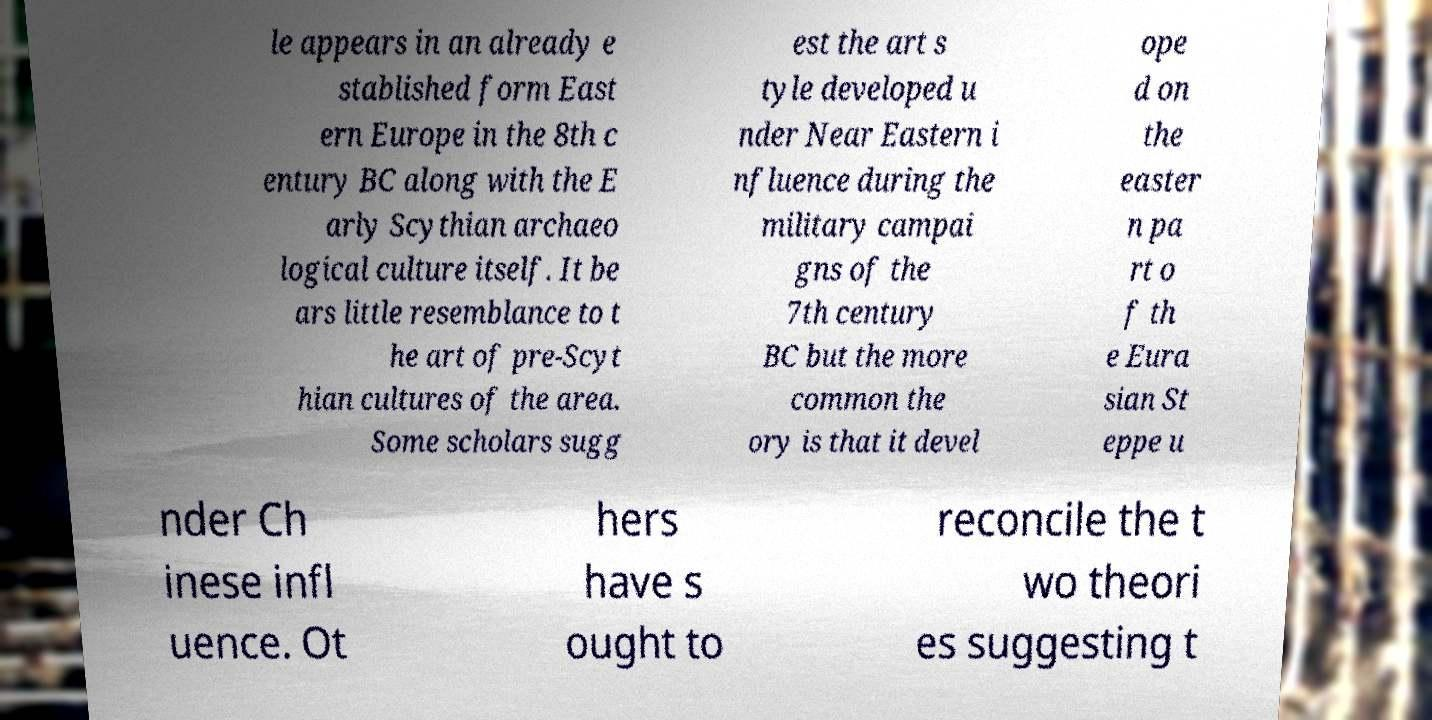Could you extract and type out the text from this image? le appears in an already e stablished form East ern Europe in the 8th c entury BC along with the E arly Scythian archaeo logical culture itself. It be ars little resemblance to t he art of pre-Scyt hian cultures of the area. Some scholars sugg est the art s tyle developed u nder Near Eastern i nfluence during the military campai gns of the 7th century BC but the more common the ory is that it devel ope d on the easter n pa rt o f th e Eura sian St eppe u nder Ch inese infl uence. Ot hers have s ought to reconcile the t wo theori es suggesting t 